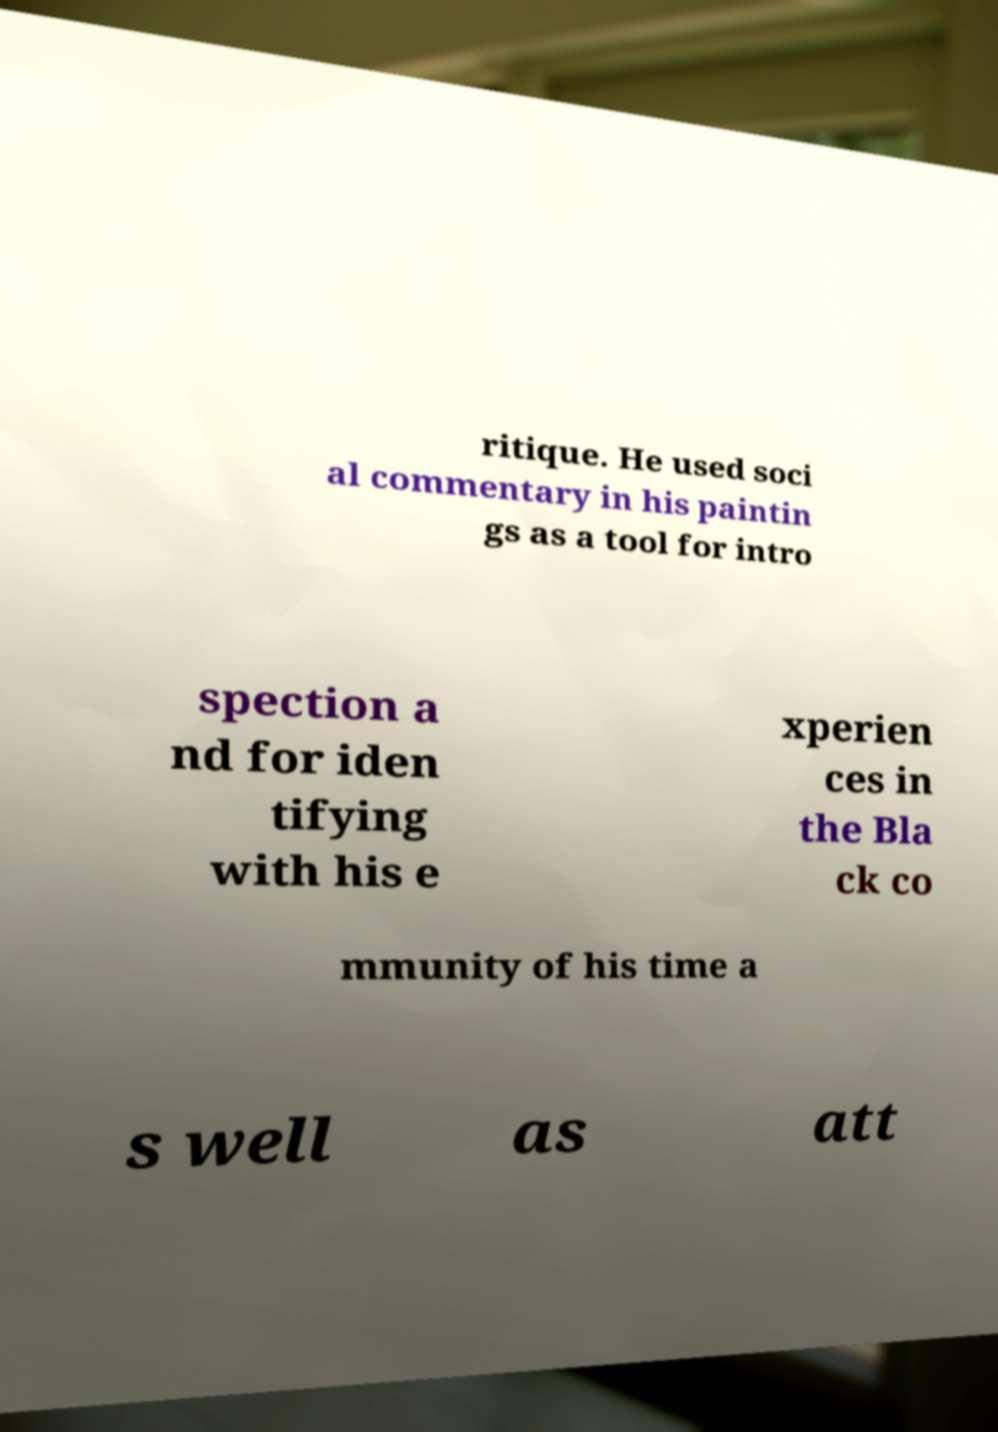Can you accurately transcribe the text from the provided image for me? ritique. He used soci al commentary in his paintin gs as a tool for intro spection a nd for iden tifying with his e xperien ces in the Bla ck co mmunity of his time a s well as att 